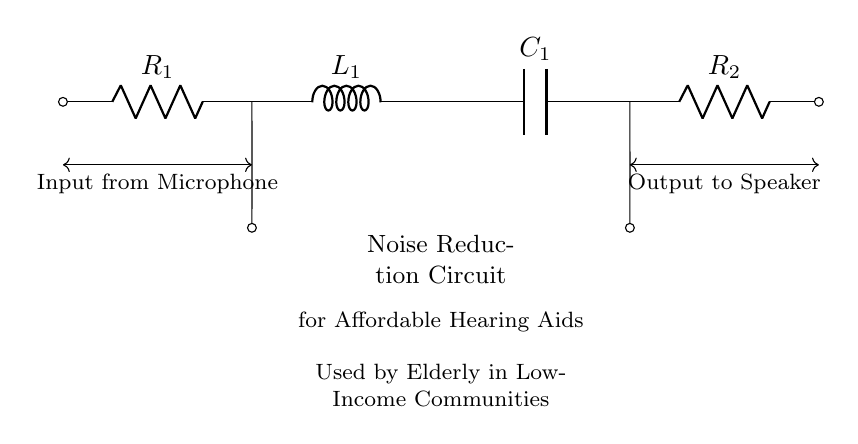What components are used in this circuit? The circuit includes two resistors, one inductor, and one capacitor. These components are specifically labeled R1, L1, C1, and R2 in the diagram.
Answer: Two resistors, one inductor, one capacitor What is the purpose of the circuit? The diagram states that the circuit is a noise reduction circuit for affordable hearing aids, indicating its function to minimize unwanted sound in the hearing aid feedback.
Answer: Noise reduction What is the connection type used in this circuit? The components are connected in series since the current flows through each component sequentially, noted by the continuous line between them without any branching.
Answer: Series How many inputs does this circuit have? There is one input indicated from the microphone at the start of the circuit, which connects to R1.
Answer: One What type of circuit is this specifically? This is a Resistor-Inductor-Capacitor circuit, as evidenced by the presence of resistive (R), inductive (L), and capacitive (C) elements.
Answer: Resistor-Inductor-Capacitor What does the output of this circuit connect to? The output connects to a speaker, as indicated in the diagram, which suggests this circuit is designed to amplify or process sound for auditory devices.
Answer: Speaker What would happen if one component fails, such as L1? If the inductor (L1) fails, it would disrupt the entire circuit's function, likely affecting its ability to filter out noise, since the inductor has a specific role in the frequency response of the circuit.
Answer: Circuit disruption 